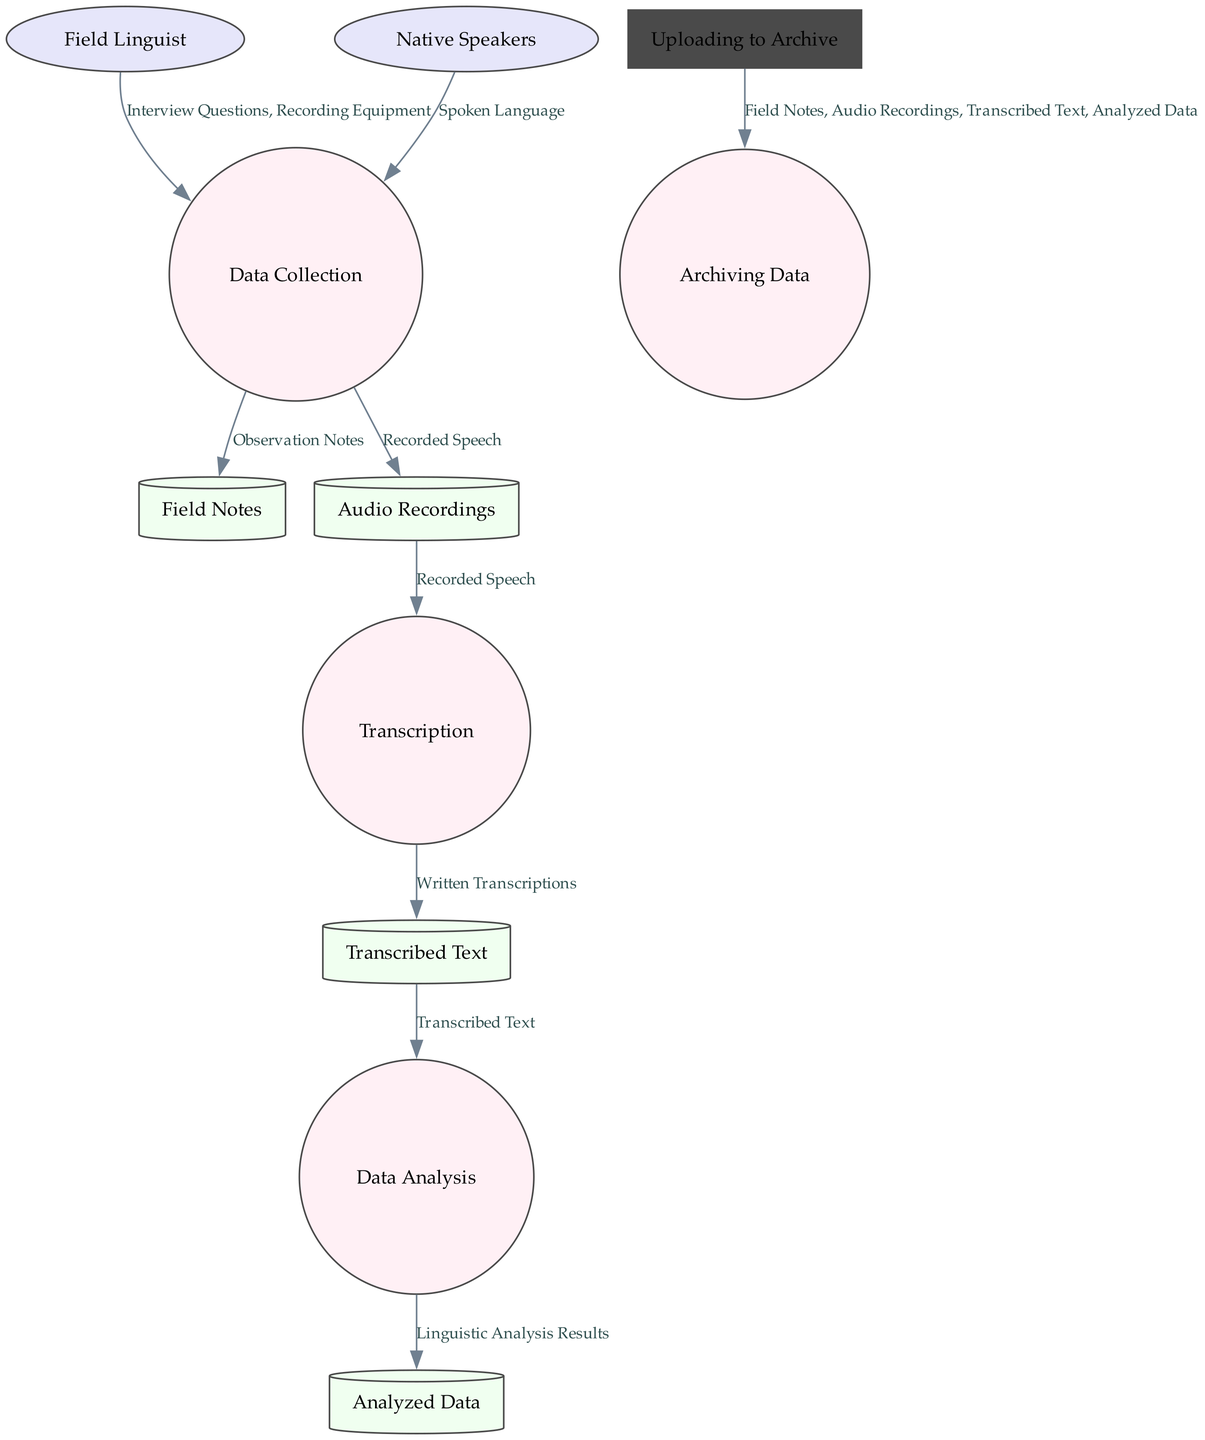What is the role of the 'Field Linguist'? The 'Field Linguist' is defined as the researcher collecting data from the field, which is indicated by its description in the node label.
Answer: The researcher collecting data from the field How many data stores are present in the diagram? Counting the nodes labeled as data stores, there are four: Field Notes, Audio Recordings, Transcribed Text, and Analyzed Data.
Answer: Four What data flows from 'Transcription' to 'Transcribed Text'? The flow from 'Transcription' to 'Transcribed Text' is labeled as "Written Transcriptions," which describes the specific data being transferred between these nodes.
Answer: Written Transcriptions Which external entity provides 'Spoken Language'? The external entity 'Native Speakers' is directly connected to the 'Data Collection' process, indicating that they provide 'Spoken Language', as detailed in the data flow.
Answer: Native Speakers What process is responsible for examining transcribed data? The process that examines the transcribed data is identified as 'Data Analysis', which is specified in the description of the flow from 'Transcribed Text' to 'Data Analysis'.
Answer: Data Analysis How does ‘Audio Recordings’ contribute to ‘Transcription’? The contribution is specified in the flow from 'Audio Recordings' to 'Transcription', where 'Recorded Speech' is the data that is being passed for further processing.
Answer: Recorded Speech What happens to the results of 'Data Analysis'? The results of 'Data Analysis' are directed towards 'Analyzed Data', as indicated in the data flow description. This shows the output of the analysis.
Answer: Analyzed Data Which two processes are involved in storing linguistic data for future reference? The two processes involved in this storage are 'Data Analysis' providing 'Analyzed Data' and 'Archiving Data' which organizes the overall data, as they facilitate the storage of results and field data respectively.
Answer: Data Analysis and Archiving Data What type of method is mentioned under the 'Data Collection' process? The method specified in the 'Data Collection' process includes "interviews" among other techniques used to gather data from native speakers.
Answer: Interviews 